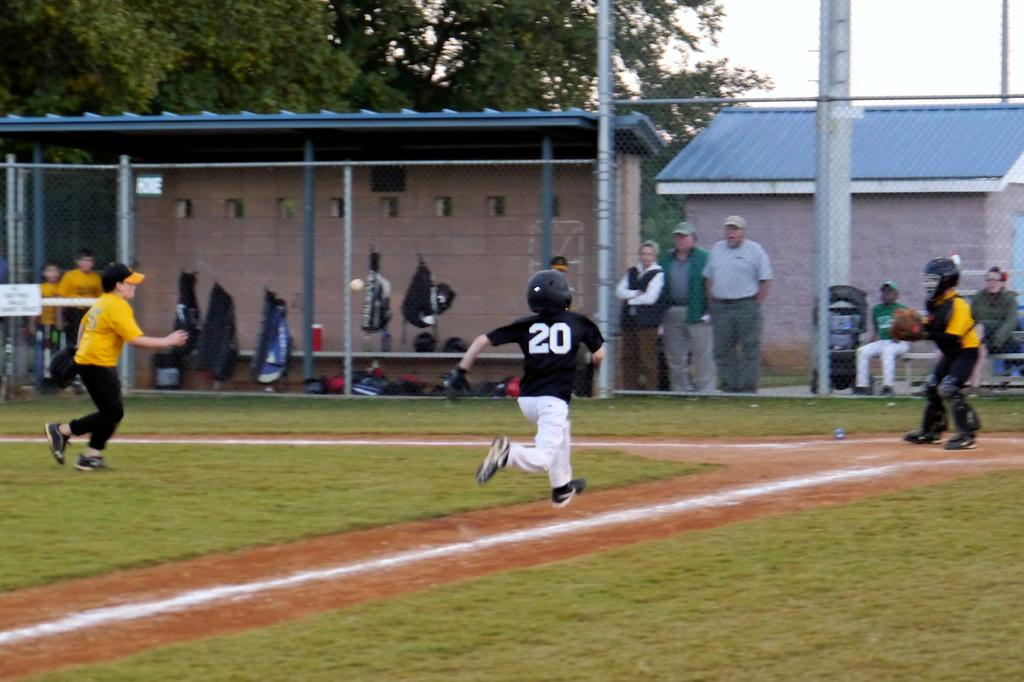Provide a one-sentence caption for the provided image. A little league game number twenty is taking a base. 